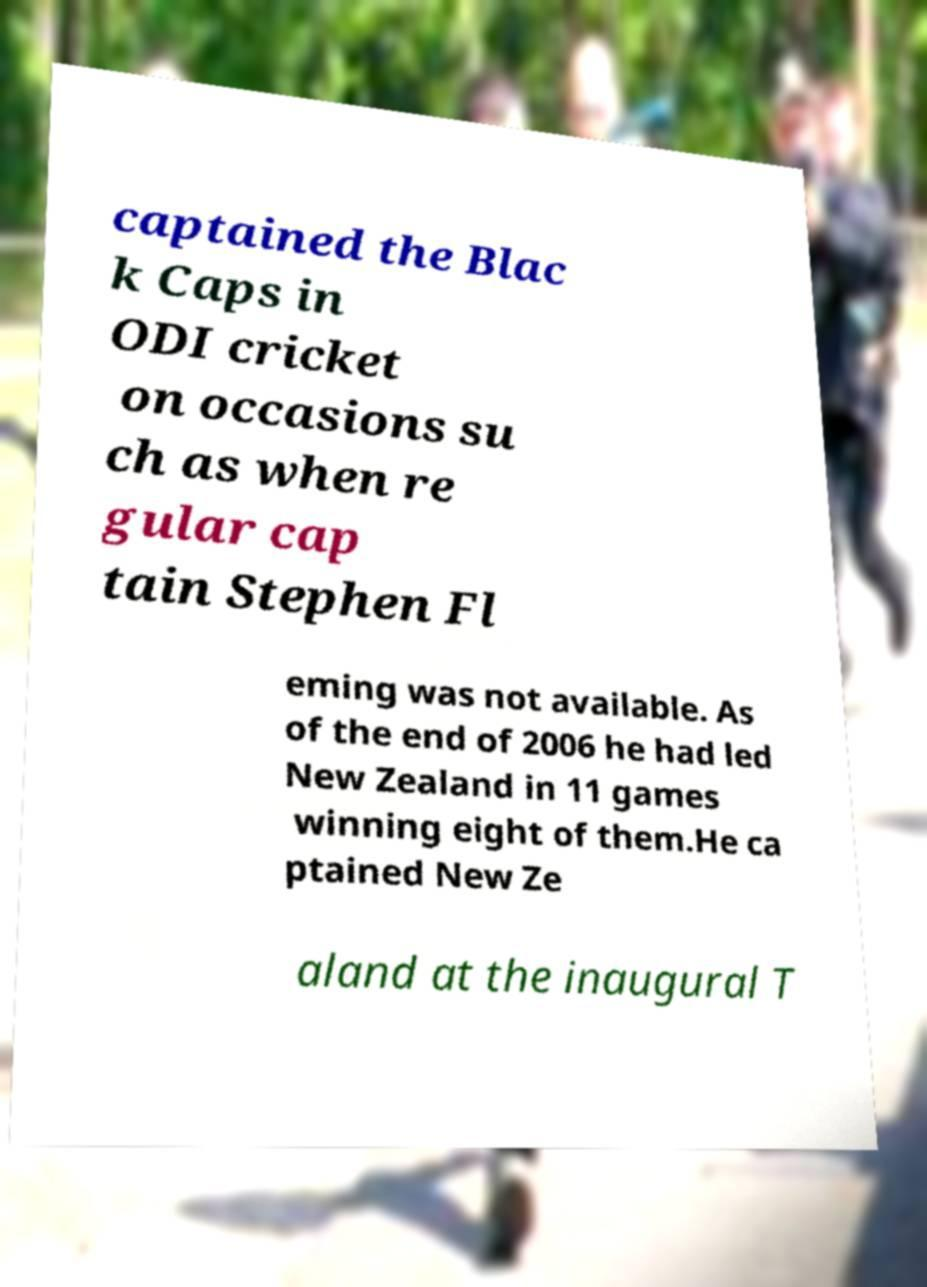There's text embedded in this image that I need extracted. Can you transcribe it verbatim? captained the Blac k Caps in ODI cricket on occasions su ch as when re gular cap tain Stephen Fl eming was not available. As of the end of 2006 he had led New Zealand in 11 games winning eight of them.He ca ptained New Ze aland at the inaugural T 